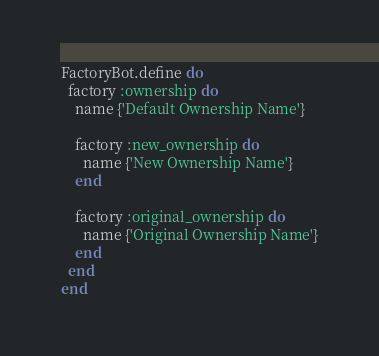<code> <loc_0><loc_0><loc_500><loc_500><_Ruby_>FactoryBot.define do
  factory :ownership do
    name {'Default Ownership Name'}

    factory :new_ownership do
      name {'New Ownership Name'}
    end

    factory :original_ownership do
      name {'Original Ownership Name'}
    end
  end
end</code> 